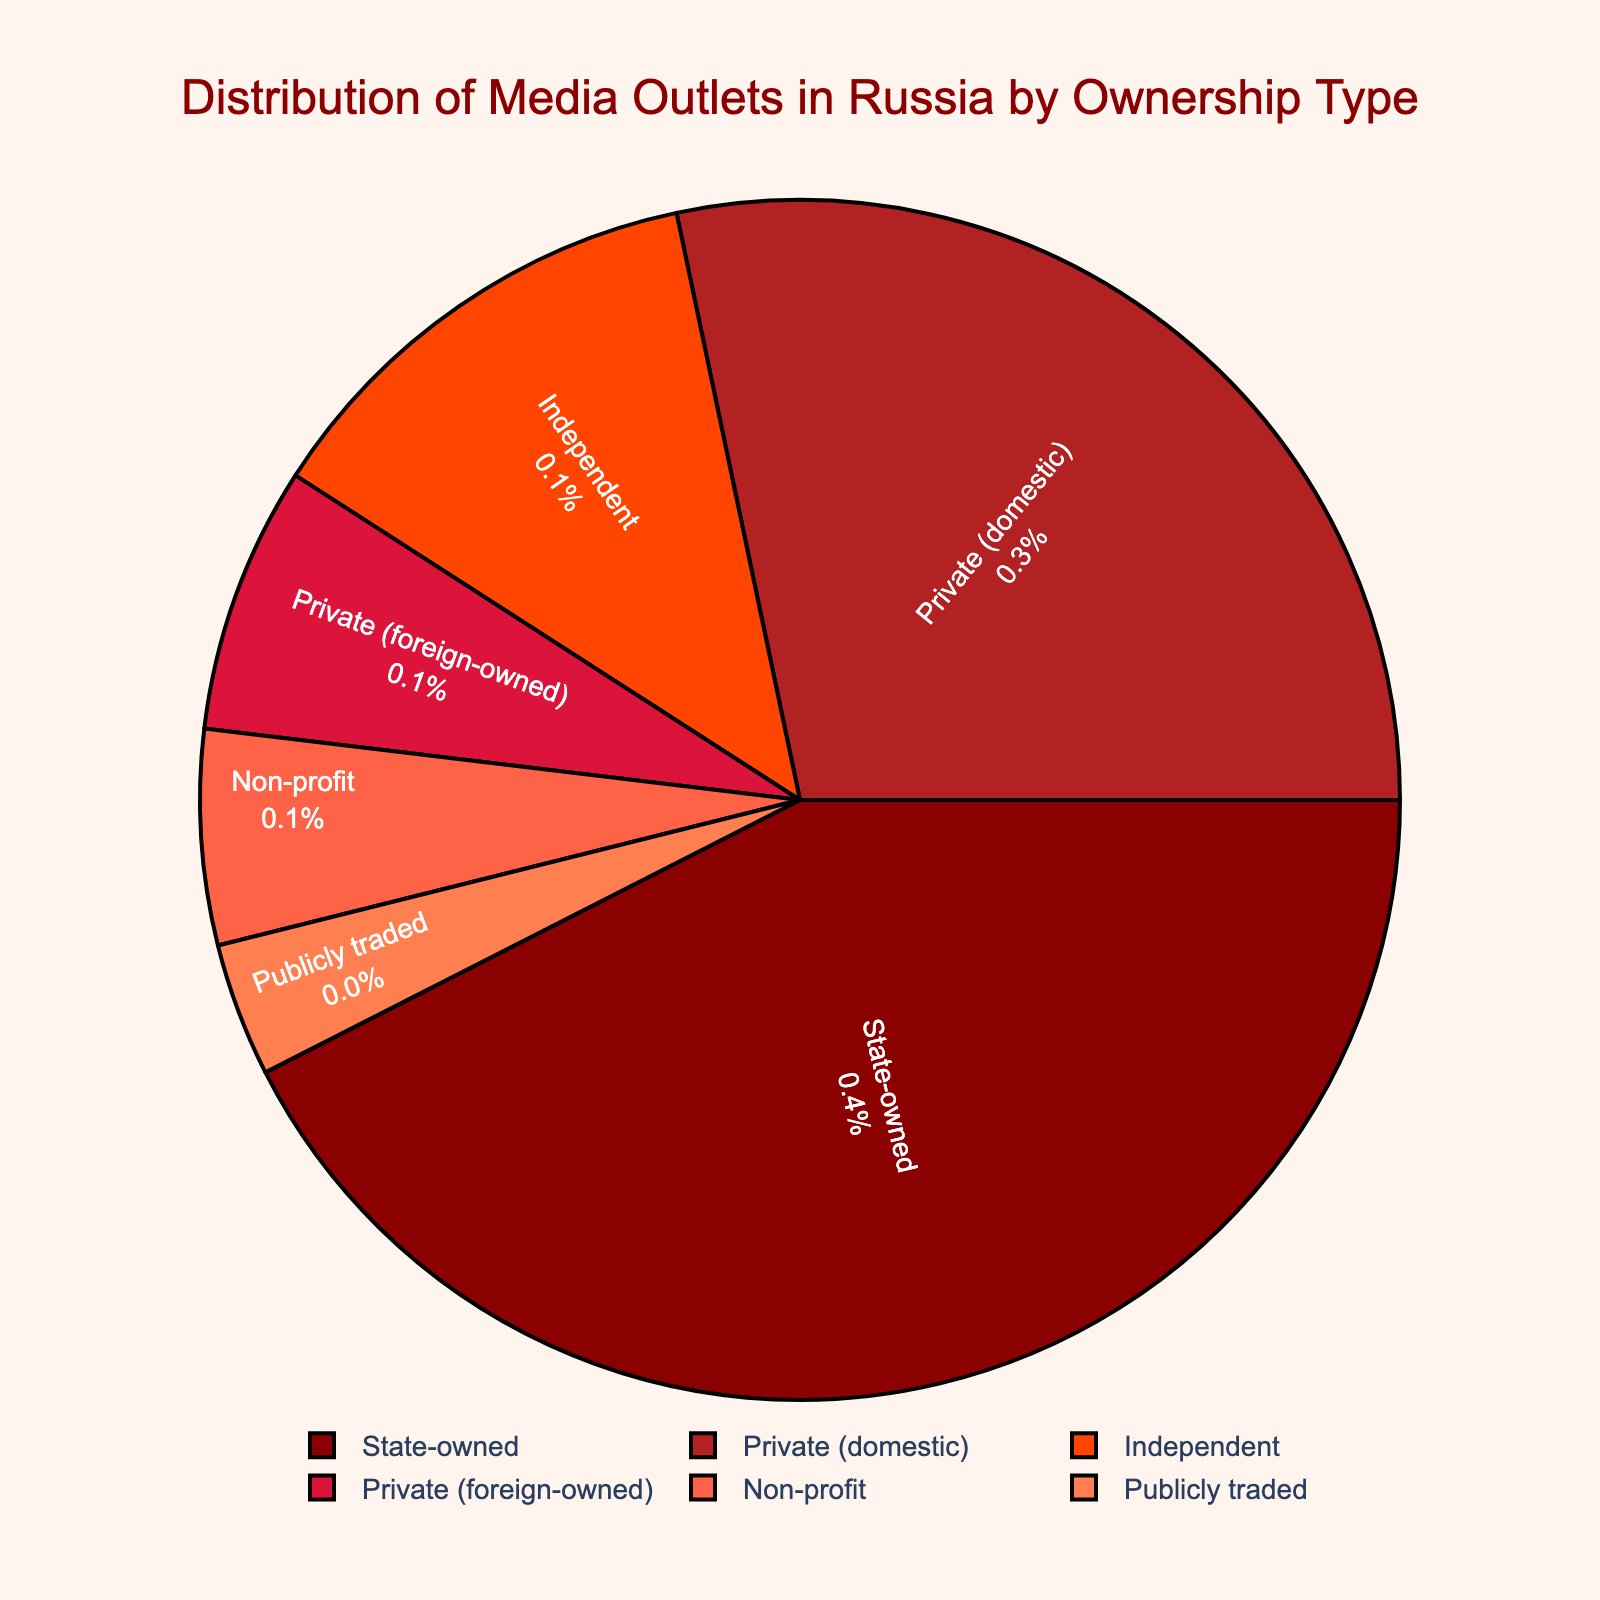What's the largest ownership type in the distribution? The largest ownership type can be identified by the largest slice of the pie chart. Looking at the largest slice, it corresponds to State-owned media.
Answer: State-owned Which ownership type has a lesser share than Private (domestic) but more than Non-profit? Private (domestic) has a 28.3% share. Non-profit has a 5.8% share. Comparing the shares, the ownership type between these is Independent with a 12.6% share.
Answer: Independent What is the total percentage of media outlets owned by private entities (both domestic and foreign)? Private (domestic) owns 28.3%, and Private (foreign-owned) owns 7.2%. Adding these together gives 28.3 + 7.2 = 35.5%.
Answer: 35.5% How much greater is the percentage of State-owned media compared to Independent media? The percentage of State-owned media is 42.5%, and Independent media is 12.6%. The difference is calculated as 42.5 - 12.6 = 29.9%.
Answer: 29.9% Which ownership types have a share of less than 10%? By looking at the shares, the ones with less than 10% are Private (foreign-owned), Non-profit, and Publicly traded with percentages 7.2%, 5.8%, and 3.6% respectively.
Answer: Private (foreign-owned), Non-profit, Publicly traded How does the share of State-owned media compare visually to that of Publicly traded media? The State-owned media slice is visually much larger than the Publicly traded media slice in the pie chart.
Answer: State-owned is much larger How much larger is the market share of Private (domestic) media compared to Non-profit media? Private (domestic) media has a 28.3% share, while Non-profit media has a 5.8% share. The difference is 28.3 - 5.8 = 22.5%.
Answer: 22.5% What percentage of the total media outlets are either Independent or Publicly traded? The shares for Independent and Publicly traded media are 12.6% and 3.6% respectively. Adding these together gives 12.6 + 3.6 = 16.2%.
Answer: 16.2% Which ownership type has the least representation in the distribution? The smallest slice of the pie chart corresponds to Publicly traded media, which has the least representation.
Answer: Publicly traded 